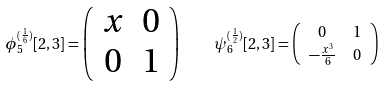<formula> <loc_0><loc_0><loc_500><loc_500>\phi _ { 5 } ^ { ( \frac { 1 } { 6 } ) } [ 2 , 3 ] = \left ( \begin{array} { c c } x & 0 \\ 0 & 1 \end{array} \right ) \quad & \psi _ { 6 } ^ { ( \frac { 1 } { 2 } ) } [ 2 , 3 ] = \left ( \begin{array} { c c } 0 & 1 \\ - \frac { x ^ { 3 } } { 6 } & 0 \end{array} \right )</formula> 